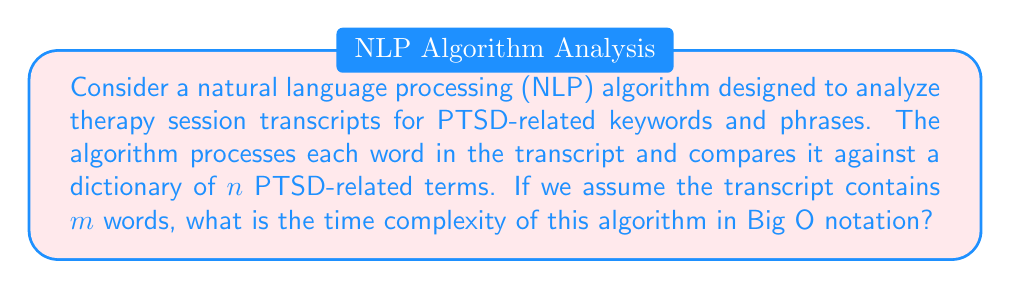Teach me how to tackle this problem. To solve this problem, let's break down the algorithm and analyze its components:

1. The algorithm processes each word in the transcript. This means we have an outer loop that iterates $m$ times (once for each word in the transcript).

2. For each word, the algorithm compares it against a dictionary of $n$ PTSD-related terms. This comparison can be thought of as an inner loop or operation that occurs $n$ times for each word.

3. The basic operation (comparison of a word to a dictionary term) is performed $m * n$ times in total.

4. Assuming the comparison operation itself takes constant time, we can express the total time complexity as:

   $$T(m,n) = O(m * n)$$

5. In Big O notation, we typically express complexity in terms of the input size. In this case, both $m$ (transcript length) and $n$ (dictionary size) can be considered input parameters that affect the algorithm's performance.

6. Therefore, we keep both variables in our final expression of time complexity.

This analysis assumes a naive approach where each word is compared against every dictionary term. In practice, more efficient data structures (like hash tables) or algorithms (like Aho-Corasick) could be used to improve performance, especially for large dictionaries. However, the question asks for the complexity of the described algorithm, not potential optimizations.
Answer: $O(m * n)$, where $m$ is the number of words in the transcript and $n$ is the number of terms in the PTSD-related dictionary. 